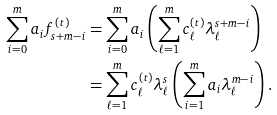Convert formula to latex. <formula><loc_0><loc_0><loc_500><loc_500>\sum _ { i = 0 } ^ { m } a _ { i } f _ { s + m - i } ^ { ( t ) } & = \sum _ { i = 0 } ^ { m } a _ { i } \left ( \sum _ { \ell = 1 } ^ { m } c _ { \ell } ^ { ( t ) } \lambda _ { \ell } ^ { s + m - i } \right ) \\ & = \sum _ { \ell = 1 } ^ { m } c _ { \ell } ^ { ( t ) } \lambda _ { \ell } ^ { s } \left ( \sum _ { i = 1 } ^ { m } a _ { i } \lambda _ { \ell } ^ { m - i } \right ) .</formula> 